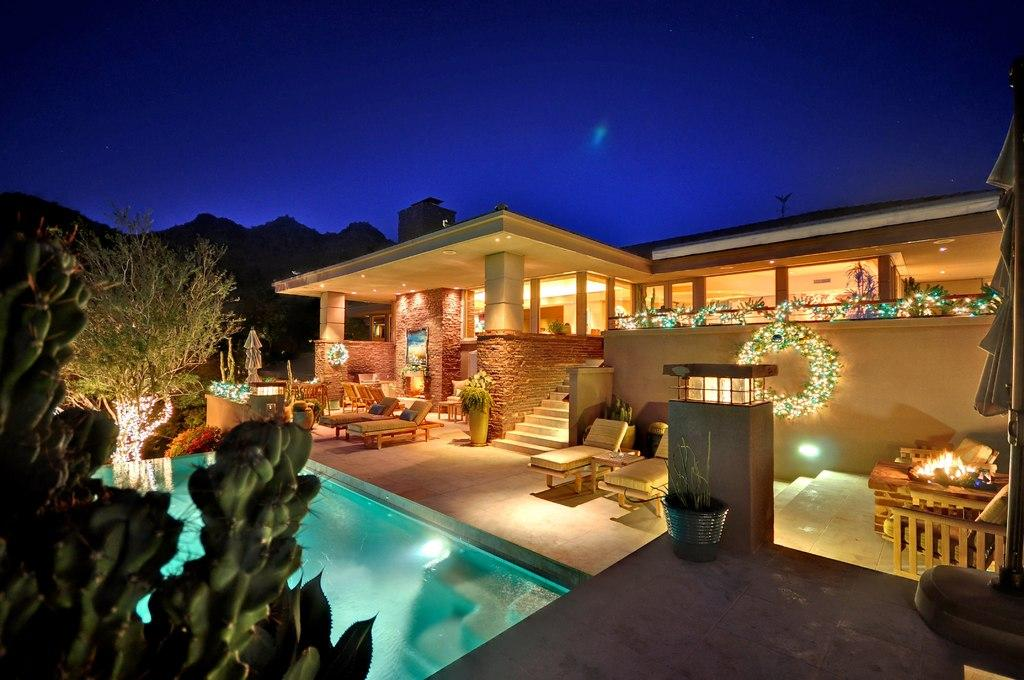What type of terrain is visible in the image? Ground and water are visible in the image. What type of vegetation can be seen in the image? Trees and plants are visible in the image. What type of structures are present in the image? There are lights, stairs, beach beds, and a building visible in the image. What is visible in the background of the image? Mountains and the sky are visible in the background of the image. What type of bomb can be seen in the image? There is no bomb present in the image. How does the heat affect the plants in the image? There is no information about the temperature or heat in the image, and therefore we cannot determine its effect on the plants. 